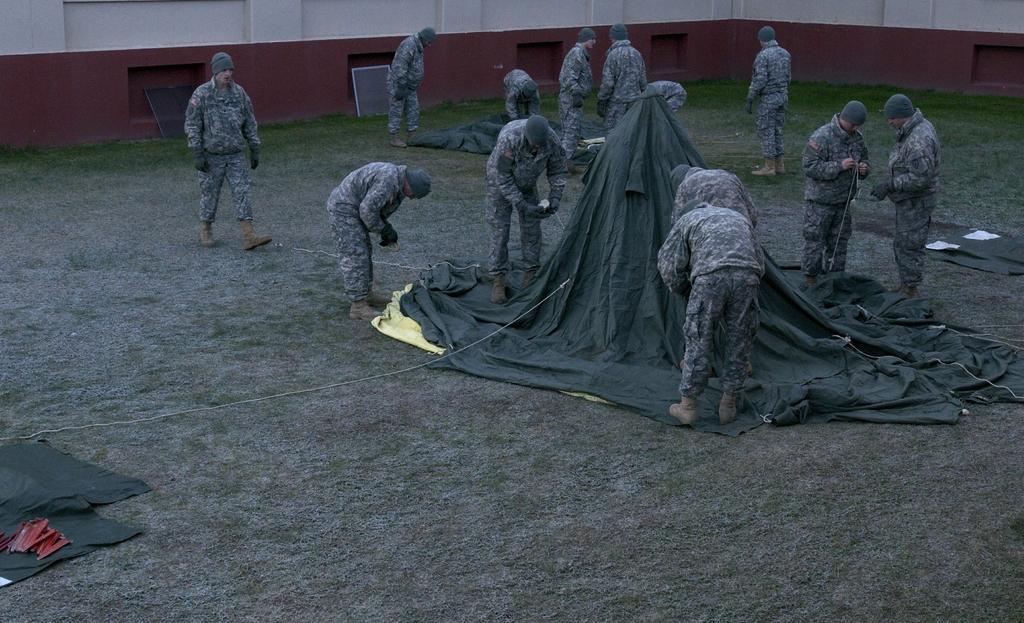Could you give a brief overview of what you see in this image? In the center of the image there are many persons. There is a tent. In the bottom of the image there is grass. In the background of the image there is wall. 